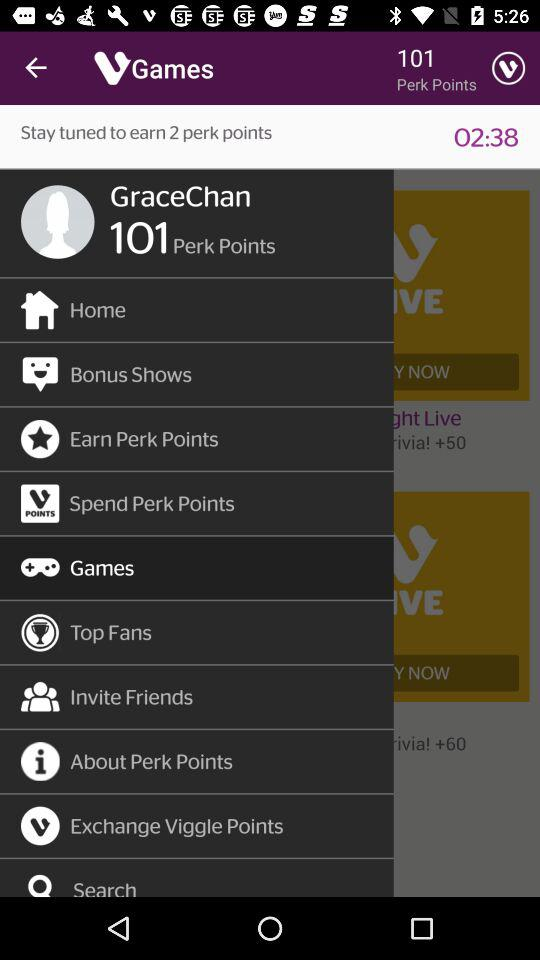How many perk points are there? There are 101 perk points. 